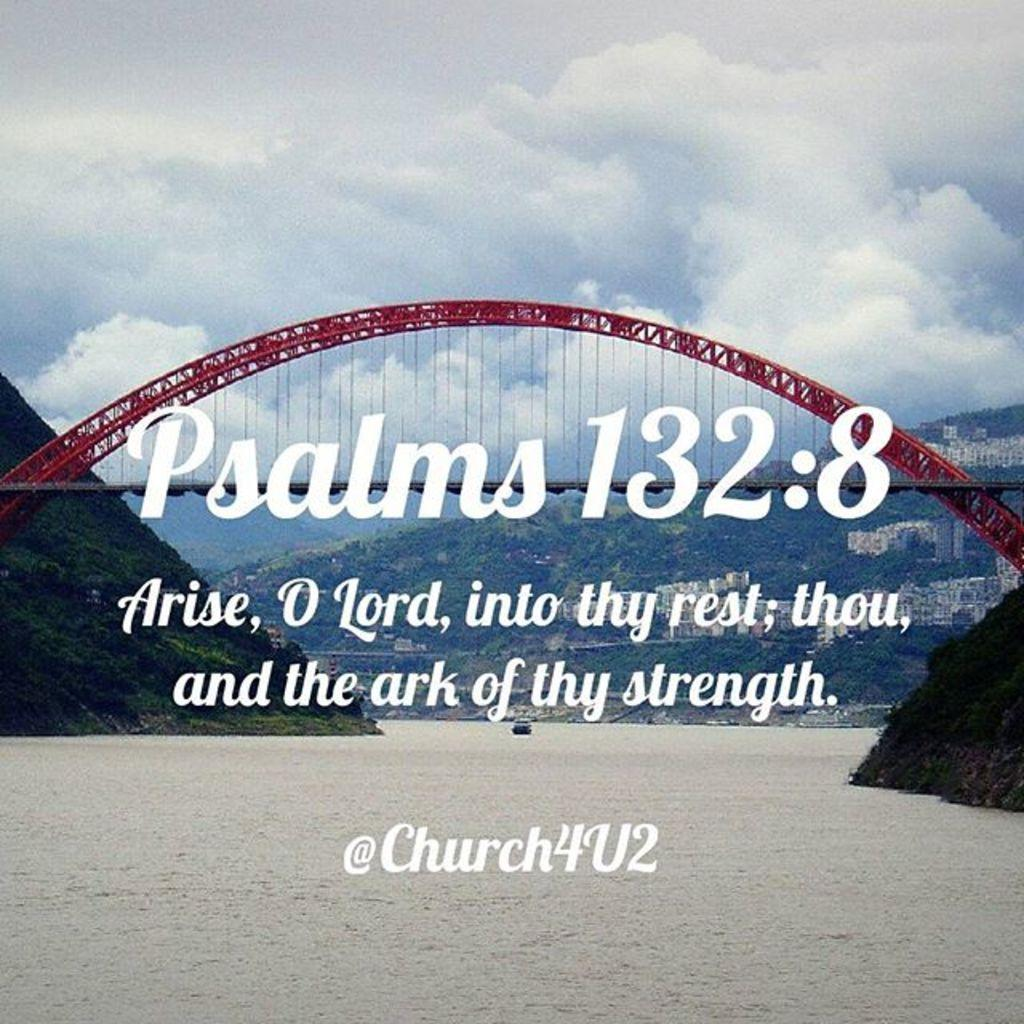<image>
Offer a succinct explanation of the picture presented. A bridge over water with a Psalms 132:8 quote. 